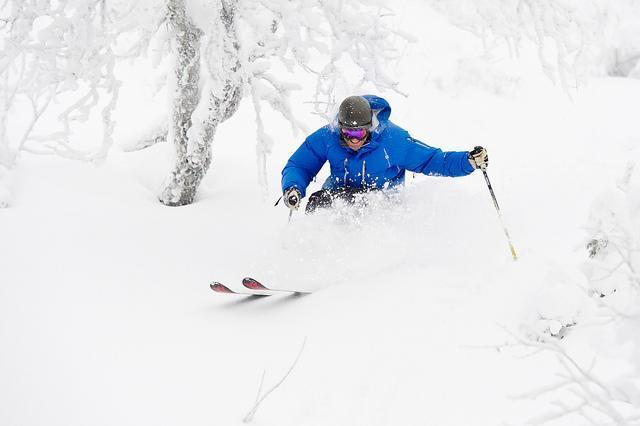How many people are there?
Give a very brief answer. 1. How many of the cats paws are on the desk?
Give a very brief answer. 0. 